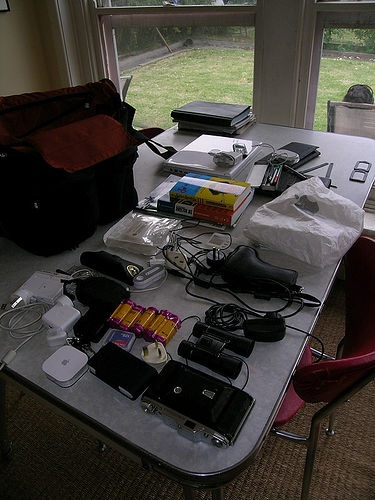Describe the objects in this image and their specific colors. I can see handbag in gray, black, and maroon tones, chair in gray, black, and maroon tones, laptop in gray, lavender, and black tones, book in gray, black, olive, darkgray, and blue tones, and chair in gray tones in this image. 